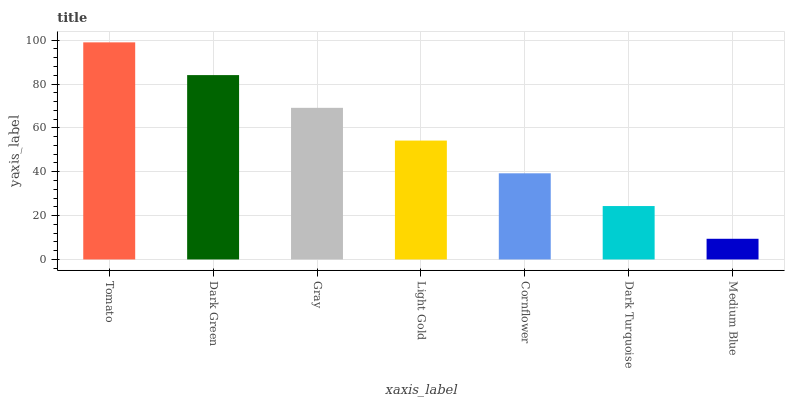Is Dark Green the minimum?
Answer yes or no. No. Is Dark Green the maximum?
Answer yes or no. No. Is Tomato greater than Dark Green?
Answer yes or no. Yes. Is Dark Green less than Tomato?
Answer yes or no. Yes. Is Dark Green greater than Tomato?
Answer yes or no. No. Is Tomato less than Dark Green?
Answer yes or no. No. Is Light Gold the high median?
Answer yes or no. Yes. Is Light Gold the low median?
Answer yes or no. Yes. Is Cornflower the high median?
Answer yes or no. No. Is Gray the low median?
Answer yes or no. No. 